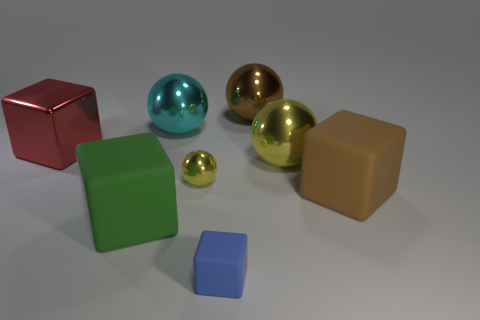Add 1 tiny metallic things. How many objects exist? 9 Subtract 1 red cubes. How many objects are left? 7 Subtract all yellow things. Subtract all cyan metal things. How many objects are left? 5 Add 6 big brown spheres. How many big brown spheres are left? 7 Add 2 tiny gray metal blocks. How many tiny gray metal blocks exist? 2 